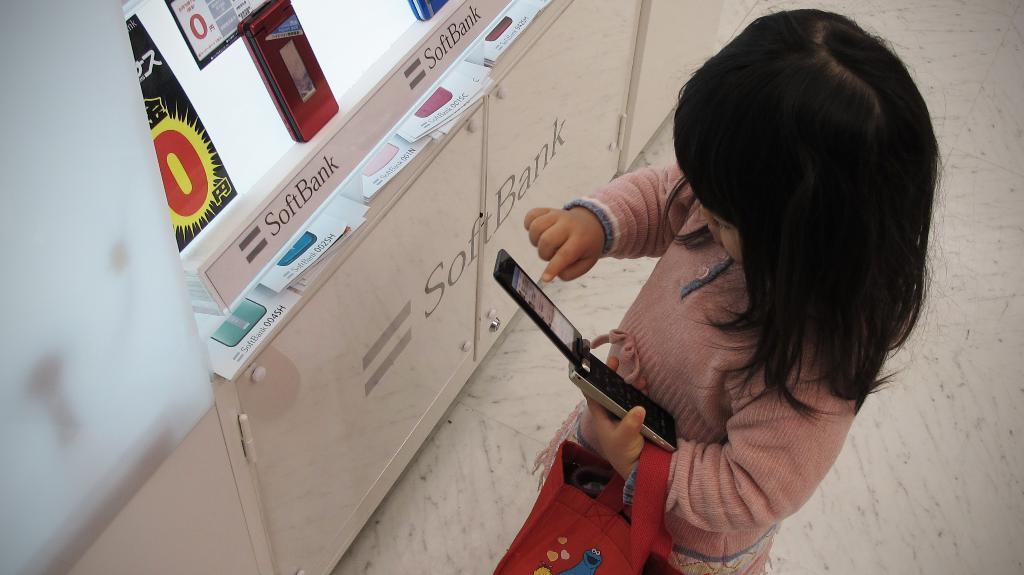Please provide a concise description of this image. In front of the image there is a girl holding the bag and a mobile in her hand. In front of her there is a display board. There are files on the wooden table. Beneath the table there are cupboards. On the left side of the image there is a glass wall. At the bottom of the image there is a floor. 